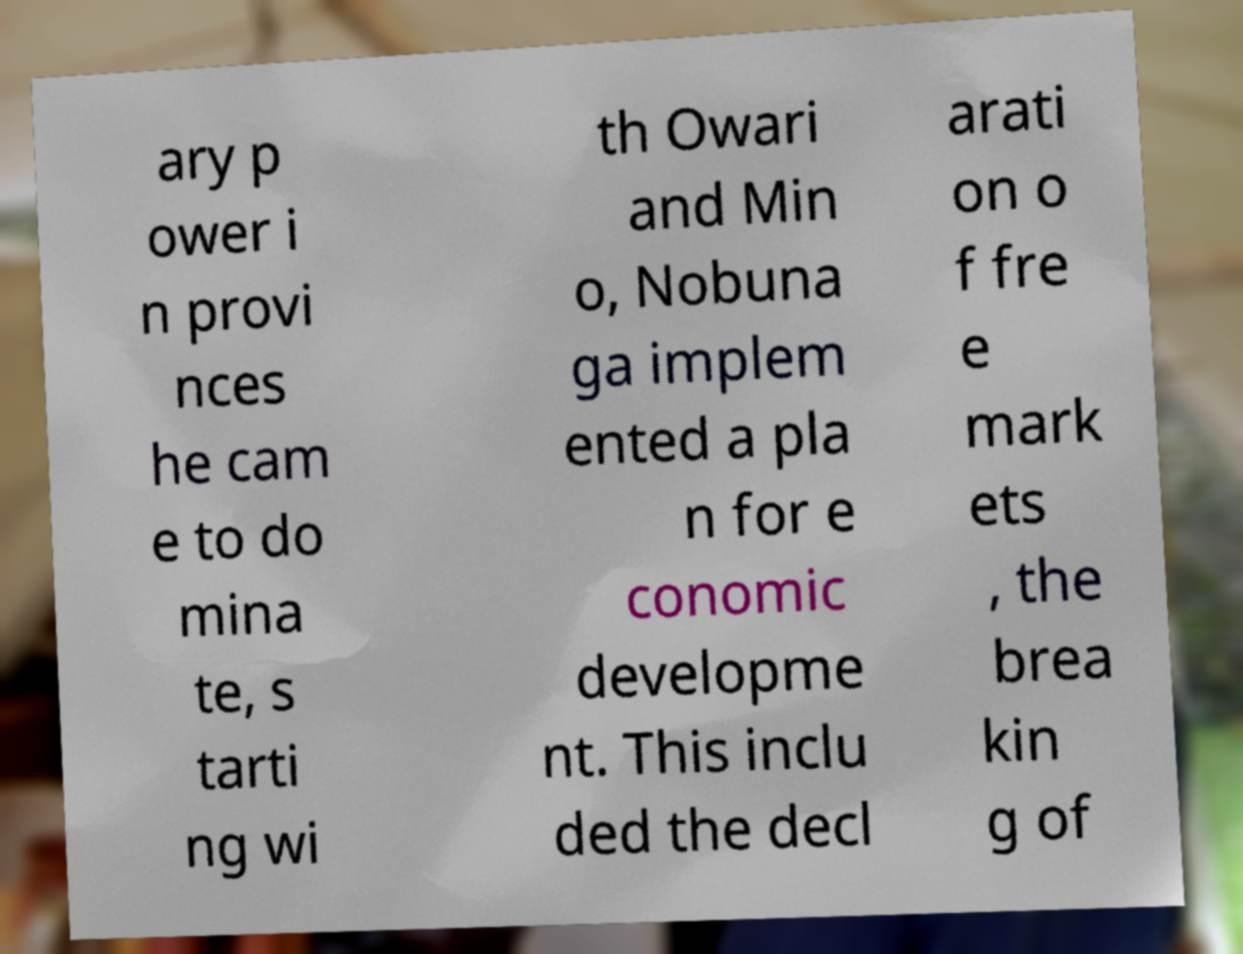What messages or text are displayed in this image? I need them in a readable, typed format. ary p ower i n provi nces he cam e to do mina te, s tarti ng wi th Owari and Min o, Nobuna ga implem ented a pla n for e conomic developme nt. This inclu ded the decl arati on o f fre e mark ets , the brea kin g of 